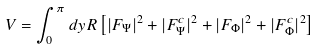Convert formula to latex. <formula><loc_0><loc_0><loc_500><loc_500>V = \int _ { 0 } ^ { \pi } d y R \left [ | F _ { \Psi } | ^ { 2 } + | F _ { \Psi } ^ { c } | ^ { 2 } + | F _ { \Phi } | ^ { 2 } + | F _ { \Phi } ^ { c } | ^ { 2 } \right ]</formula> 